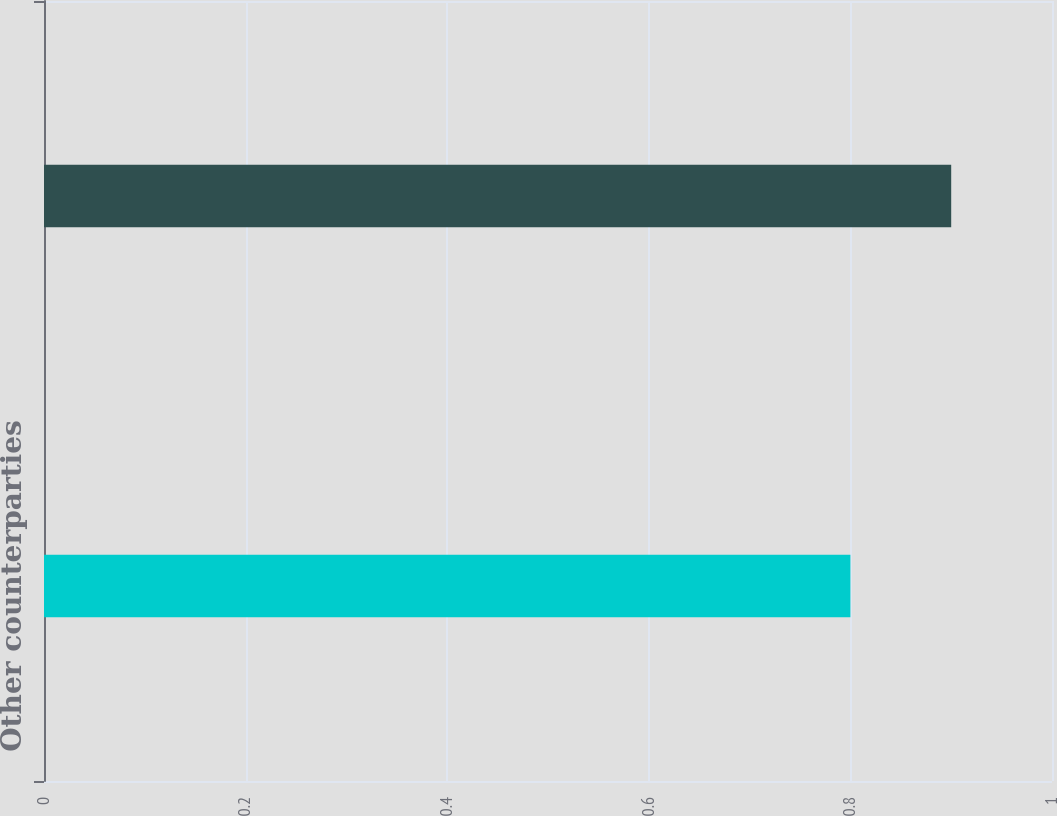Convert chart. <chart><loc_0><loc_0><loc_500><loc_500><bar_chart><fcel>Other counterparties<fcel>Total<nl><fcel>0.8<fcel>0.9<nl></chart> 